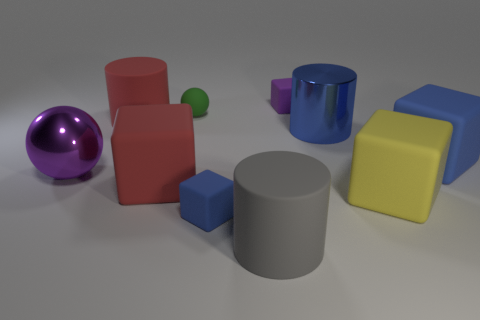What number of other things are there of the same shape as the purple shiny object?
Make the answer very short. 1. What number of red things are big blocks or balls?
Provide a short and direct response. 1. Does the tiny rubber cube that is on the left side of the purple block have the same color as the large metal cylinder?
Keep it short and to the point. Yes. What is the shape of the big yellow thing that is made of the same material as the tiny sphere?
Your response must be concise. Cube. There is a matte object that is behind the big red cube and left of the small sphere; what is its color?
Give a very brief answer. Red. There is a blue thing that is in front of the blue cube that is right of the tiny purple object; what is its size?
Ensure brevity in your answer.  Small. Are there any small matte cubes of the same color as the large shiny ball?
Ensure brevity in your answer.  Yes. Are there an equal number of red cylinders that are on the right side of the large yellow matte thing and big cyan blocks?
Provide a succinct answer. Yes. How many red cylinders are there?
Provide a succinct answer. 1. The big matte thing that is right of the small purple object and left of the big blue rubber block has what shape?
Provide a succinct answer. Cube. 